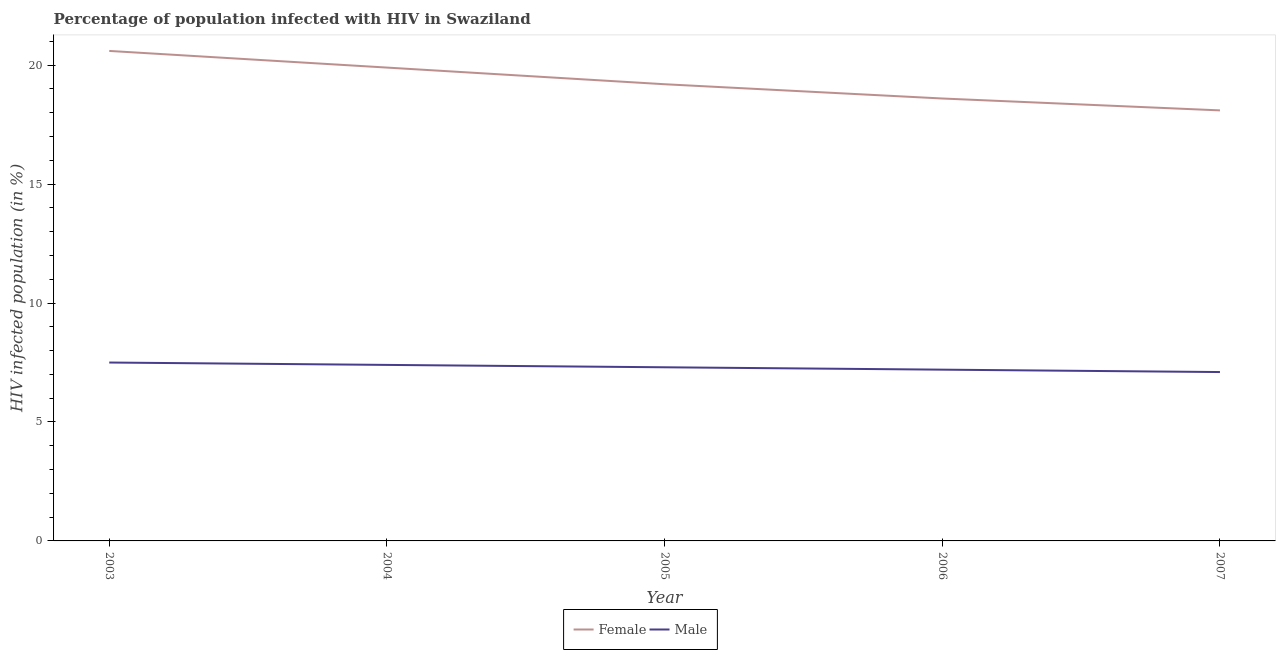Does the line corresponding to percentage of females who are infected with hiv intersect with the line corresponding to percentage of males who are infected with hiv?
Give a very brief answer. No. Is the number of lines equal to the number of legend labels?
Give a very brief answer. Yes. Across all years, what is the maximum percentage of males who are infected with hiv?
Keep it short and to the point. 7.5. In which year was the percentage of females who are infected with hiv maximum?
Offer a terse response. 2003. In which year was the percentage of females who are infected with hiv minimum?
Make the answer very short. 2007. What is the total percentage of females who are infected with hiv in the graph?
Your answer should be compact. 96.4. What is the difference between the percentage of males who are infected with hiv in 2004 and that in 2007?
Provide a succinct answer. 0.3. What is the difference between the percentage of males who are infected with hiv in 2007 and the percentage of females who are infected with hiv in 2005?
Your answer should be compact. -12.1. What is the average percentage of females who are infected with hiv per year?
Your answer should be very brief. 19.28. In the year 2003, what is the difference between the percentage of females who are infected with hiv and percentage of males who are infected with hiv?
Keep it short and to the point. 13.1. In how many years, is the percentage of males who are infected with hiv greater than 7 %?
Ensure brevity in your answer.  5. What is the ratio of the percentage of males who are infected with hiv in 2004 to that in 2007?
Make the answer very short. 1.04. Is the difference between the percentage of females who are infected with hiv in 2006 and 2007 greater than the difference between the percentage of males who are infected with hiv in 2006 and 2007?
Offer a terse response. Yes. What is the difference between the highest and the second highest percentage of males who are infected with hiv?
Your response must be concise. 0.1. What is the difference between the highest and the lowest percentage of females who are infected with hiv?
Your answer should be very brief. 2.5. In how many years, is the percentage of females who are infected with hiv greater than the average percentage of females who are infected with hiv taken over all years?
Your answer should be very brief. 2. Does the percentage of females who are infected with hiv monotonically increase over the years?
Your answer should be very brief. No. How many lines are there?
Give a very brief answer. 2. How many years are there in the graph?
Provide a succinct answer. 5. Are the values on the major ticks of Y-axis written in scientific E-notation?
Your answer should be compact. No. Where does the legend appear in the graph?
Ensure brevity in your answer.  Bottom center. How many legend labels are there?
Make the answer very short. 2. What is the title of the graph?
Provide a short and direct response. Percentage of population infected with HIV in Swaziland. Does "US$" appear as one of the legend labels in the graph?
Offer a very short reply. No. What is the label or title of the X-axis?
Keep it short and to the point. Year. What is the label or title of the Y-axis?
Offer a very short reply. HIV infected population (in %). What is the HIV infected population (in %) of Female in 2003?
Your answer should be compact. 20.6. What is the HIV infected population (in %) in Female in 2004?
Provide a short and direct response. 19.9. What is the HIV infected population (in %) of Male in 2004?
Your answer should be compact. 7.4. What is the HIV infected population (in %) in Male in 2005?
Ensure brevity in your answer.  7.3. What is the HIV infected population (in %) of Female in 2006?
Give a very brief answer. 18.6. Across all years, what is the maximum HIV infected population (in %) in Female?
Provide a short and direct response. 20.6. Across all years, what is the maximum HIV infected population (in %) in Male?
Your answer should be very brief. 7.5. What is the total HIV infected population (in %) of Female in the graph?
Make the answer very short. 96.4. What is the total HIV infected population (in %) in Male in the graph?
Ensure brevity in your answer.  36.5. What is the difference between the HIV infected population (in %) in Female in 2003 and that in 2004?
Keep it short and to the point. 0.7. What is the difference between the HIV infected population (in %) of Male in 2003 and that in 2005?
Offer a terse response. 0.2. What is the difference between the HIV infected population (in %) in Male in 2003 and that in 2006?
Offer a terse response. 0.3. What is the difference between the HIV infected population (in %) in Male in 2003 and that in 2007?
Offer a terse response. 0.4. What is the difference between the HIV infected population (in %) in Male in 2004 and that in 2005?
Provide a succinct answer. 0.1. What is the difference between the HIV infected population (in %) in Male in 2004 and that in 2006?
Provide a short and direct response. 0.2. What is the difference between the HIV infected population (in %) of Female in 2004 and that in 2007?
Offer a terse response. 1.8. What is the difference between the HIV infected population (in %) in Male in 2004 and that in 2007?
Offer a terse response. 0.3. What is the difference between the HIV infected population (in %) in Female in 2005 and that in 2006?
Make the answer very short. 0.6. What is the difference between the HIV infected population (in %) of Male in 2005 and that in 2006?
Ensure brevity in your answer.  0.1. What is the difference between the HIV infected population (in %) in Female in 2005 and that in 2007?
Keep it short and to the point. 1.1. What is the difference between the HIV infected population (in %) in Male in 2005 and that in 2007?
Offer a very short reply. 0.2. What is the difference between the HIV infected population (in %) of Female in 2006 and that in 2007?
Give a very brief answer. 0.5. What is the difference between the HIV infected population (in %) in Male in 2006 and that in 2007?
Your answer should be compact. 0.1. What is the difference between the HIV infected population (in %) in Female in 2003 and the HIV infected population (in %) in Male in 2005?
Make the answer very short. 13.3. What is the difference between the HIV infected population (in %) in Female in 2003 and the HIV infected population (in %) in Male in 2006?
Your answer should be compact. 13.4. What is the difference between the HIV infected population (in %) of Female in 2004 and the HIV infected population (in %) of Male in 2006?
Keep it short and to the point. 12.7. What is the difference between the HIV infected population (in %) of Female in 2004 and the HIV infected population (in %) of Male in 2007?
Give a very brief answer. 12.8. What is the difference between the HIV infected population (in %) of Female in 2005 and the HIV infected population (in %) of Male in 2006?
Provide a succinct answer. 12. What is the difference between the HIV infected population (in %) of Female in 2006 and the HIV infected population (in %) of Male in 2007?
Offer a very short reply. 11.5. What is the average HIV infected population (in %) of Female per year?
Make the answer very short. 19.28. In the year 2003, what is the difference between the HIV infected population (in %) in Female and HIV infected population (in %) in Male?
Your response must be concise. 13.1. In the year 2004, what is the difference between the HIV infected population (in %) in Female and HIV infected population (in %) in Male?
Provide a succinct answer. 12.5. In the year 2006, what is the difference between the HIV infected population (in %) in Female and HIV infected population (in %) in Male?
Your answer should be compact. 11.4. In the year 2007, what is the difference between the HIV infected population (in %) in Female and HIV infected population (in %) in Male?
Provide a short and direct response. 11. What is the ratio of the HIV infected population (in %) in Female in 2003 to that in 2004?
Your answer should be compact. 1.04. What is the ratio of the HIV infected population (in %) in Male in 2003 to that in 2004?
Make the answer very short. 1.01. What is the ratio of the HIV infected population (in %) of Female in 2003 to that in 2005?
Offer a very short reply. 1.07. What is the ratio of the HIV infected population (in %) of Male in 2003 to that in 2005?
Offer a very short reply. 1.03. What is the ratio of the HIV infected population (in %) of Female in 2003 to that in 2006?
Offer a terse response. 1.11. What is the ratio of the HIV infected population (in %) in Male in 2003 to that in 2006?
Give a very brief answer. 1.04. What is the ratio of the HIV infected population (in %) of Female in 2003 to that in 2007?
Your answer should be compact. 1.14. What is the ratio of the HIV infected population (in %) in Male in 2003 to that in 2007?
Make the answer very short. 1.06. What is the ratio of the HIV infected population (in %) of Female in 2004 to that in 2005?
Provide a succinct answer. 1.04. What is the ratio of the HIV infected population (in %) of Male in 2004 to that in 2005?
Offer a terse response. 1.01. What is the ratio of the HIV infected population (in %) in Female in 2004 to that in 2006?
Keep it short and to the point. 1.07. What is the ratio of the HIV infected population (in %) in Male in 2004 to that in 2006?
Your response must be concise. 1.03. What is the ratio of the HIV infected population (in %) in Female in 2004 to that in 2007?
Your response must be concise. 1.1. What is the ratio of the HIV infected population (in %) of Male in 2004 to that in 2007?
Your answer should be compact. 1.04. What is the ratio of the HIV infected population (in %) of Female in 2005 to that in 2006?
Your answer should be compact. 1.03. What is the ratio of the HIV infected population (in %) of Male in 2005 to that in 2006?
Your answer should be very brief. 1.01. What is the ratio of the HIV infected population (in %) of Female in 2005 to that in 2007?
Give a very brief answer. 1.06. What is the ratio of the HIV infected population (in %) of Male in 2005 to that in 2007?
Offer a very short reply. 1.03. What is the ratio of the HIV infected population (in %) of Female in 2006 to that in 2007?
Ensure brevity in your answer.  1.03. What is the ratio of the HIV infected population (in %) in Male in 2006 to that in 2007?
Your answer should be compact. 1.01. What is the difference between the highest and the second highest HIV infected population (in %) in Female?
Keep it short and to the point. 0.7. What is the difference between the highest and the second highest HIV infected population (in %) in Male?
Provide a succinct answer. 0.1. What is the difference between the highest and the lowest HIV infected population (in %) of Male?
Make the answer very short. 0.4. 